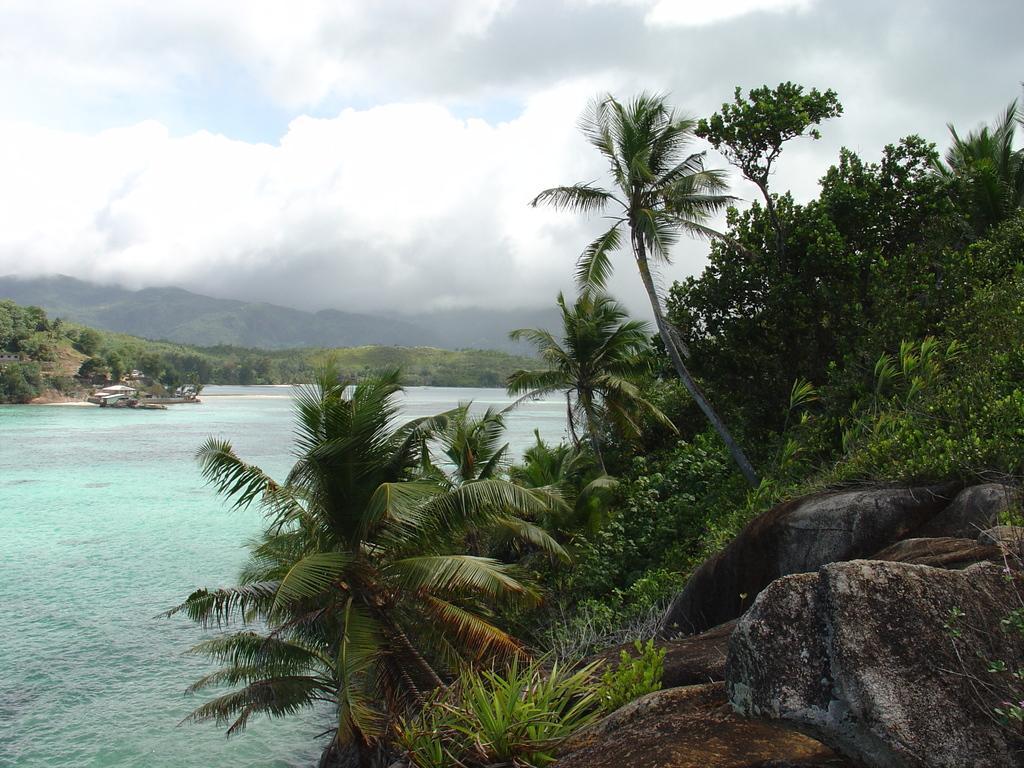In one or two sentences, can you explain what this image depicts? This is a landscape image, on the right side of the image there are trees, rocks and plants, on the left side of the image there is a water body, behind it there are trees, mountains and clouds. 